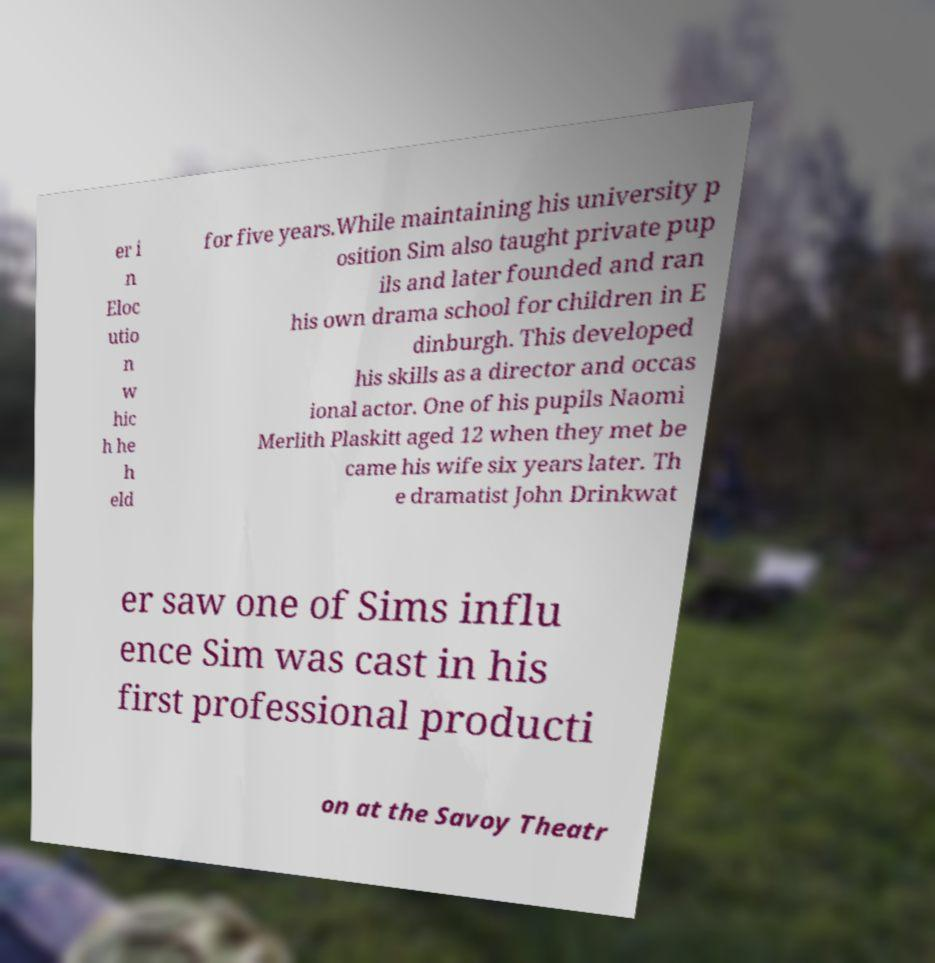There's text embedded in this image that I need extracted. Can you transcribe it verbatim? er i n Eloc utio n w hic h he h eld for five years.While maintaining his university p osition Sim also taught private pup ils and later founded and ran his own drama school for children in E dinburgh. This developed his skills as a director and occas ional actor. One of his pupils Naomi Merlith Plaskitt aged 12 when they met be came his wife six years later. Th e dramatist John Drinkwat er saw one of Sims influ ence Sim was cast in his first professional producti on at the Savoy Theatr 